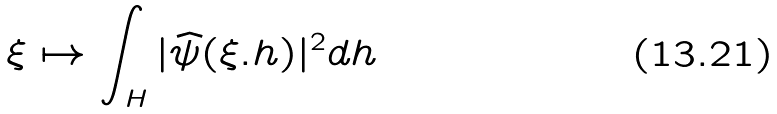Convert formula to latex. <formula><loc_0><loc_0><loc_500><loc_500>\xi \mapsto \int _ { H } | \widehat { \psi } ( \xi . h ) | ^ { 2 } d h</formula> 